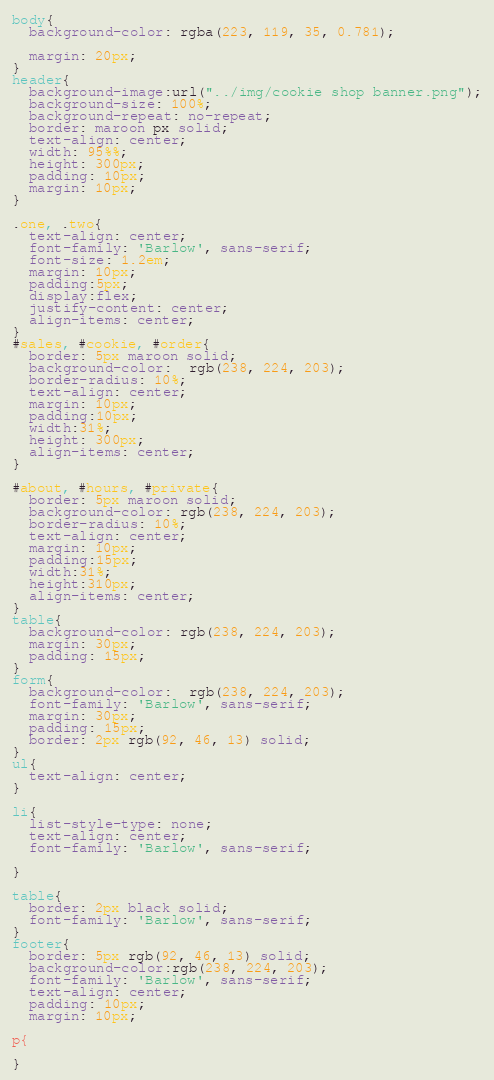Convert code to text. <code><loc_0><loc_0><loc_500><loc_500><_CSS_>body{
  background-color: rgba(223, 119, 35, 0.781);
  
  margin: 20px;
}
header{
  background-image:url("../img/cookie shop banner.png");
  background-size: 100%;
  background-repeat: no-repeat;
  border: maroon px solid;
  text-align: center;
  width: 95%%;
  height: 300px;
  padding: 10px;
  margin: 10px;
}

.one, .two{
  text-align: center;
  font-family: 'Barlow', sans-serif;
  font-size: 1.2em;
  margin: 10px;
  padding:5px;
  display:flex;
  justify-content: center;
  align-items: center;
}
#sales, #cookie, #order{
  border: 5px maroon solid;
  background-color:  rgb(238, 224, 203);
  border-radius: 10%;
  text-align: center;
  margin: 10px;
  padding:10px;
  width:31%;
  height: 300px;
  align-items: center;
}

#about, #hours, #private{
  border: 5px maroon solid;
  background-color: rgb(238, 224, 203);
  border-radius: 10%;
  text-align: center;
  margin: 10px;
  padding:15px;
  width:31%;
  height:310px;
  align-items: center;
}
table{
  background-color: rgb(238, 224, 203);
  margin: 30px;
  padding: 15px;
}
form{
  background-color:  rgb(238, 224, 203);
  font-family: 'Barlow', sans-serif;
  margin: 30px;
  padding: 15px;
  border: 2px rgb(92, 46, 13) solid;
}
ul{
  text-align: center;
}

li{
  list-style-type: none;
  text-align: center;
  font-family: 'Barlow', sans-serif;

}

table{
  border: 2px black solid;
  font-family: 'Barlow', sans-serif;
}
footer{
  border: 5px rgb(92, 46, 13) solid;
  background-color:rgb(238, 224, 203);
  font-family: 'Barlow', sans-serif;
  text-align: center;
  padding: 10px;
  margin: 10px;

p{
 
}</code> 